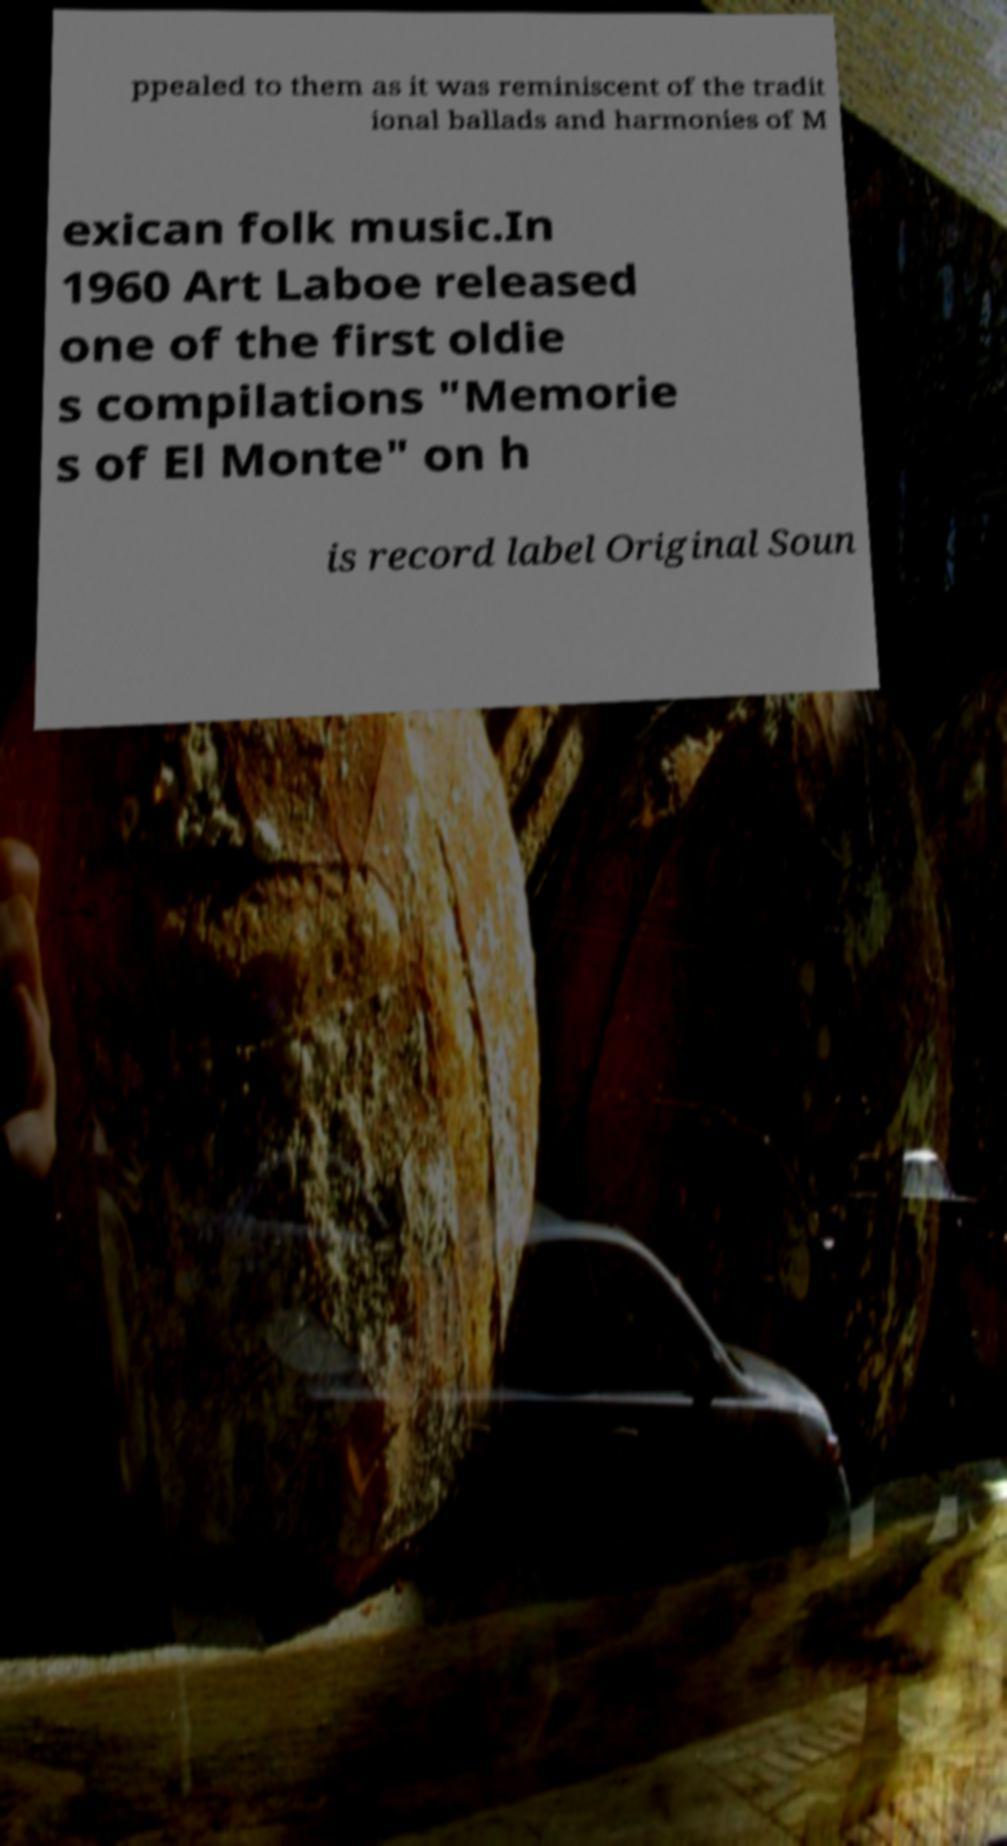Can you read and provide the text displayed in the image?This photo seems to have some interesting text. Can you extract and type it out for me? ppealed to them as it was reminiscent of the tradit ional ballads and harmonies of M exican folk music.In 1960 Art Laboe released one of the first oldie s compilations "Memorie s of El Monte" on h is record label Original Soun 